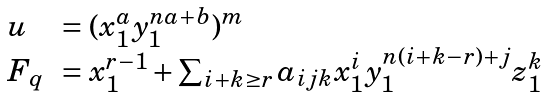<formula> <loc_0><loc_0><loc_500><loc_500>\begin{array} { l l } u & = ( x _ { 1 } ^ { a } y _ { 1 } ^ { n a + b } ) ^ { m } \\ F _ { q } & = x _ { 1 } ^ { r - 1 } + \sum _ { i + k \geq r } a _ { i j k } x _ { 1 } ^ { i } y _ { 1 } ^ { n ( i + k - r ) + j } z _ { 1 } ^ { k } \end{array}</formula> 